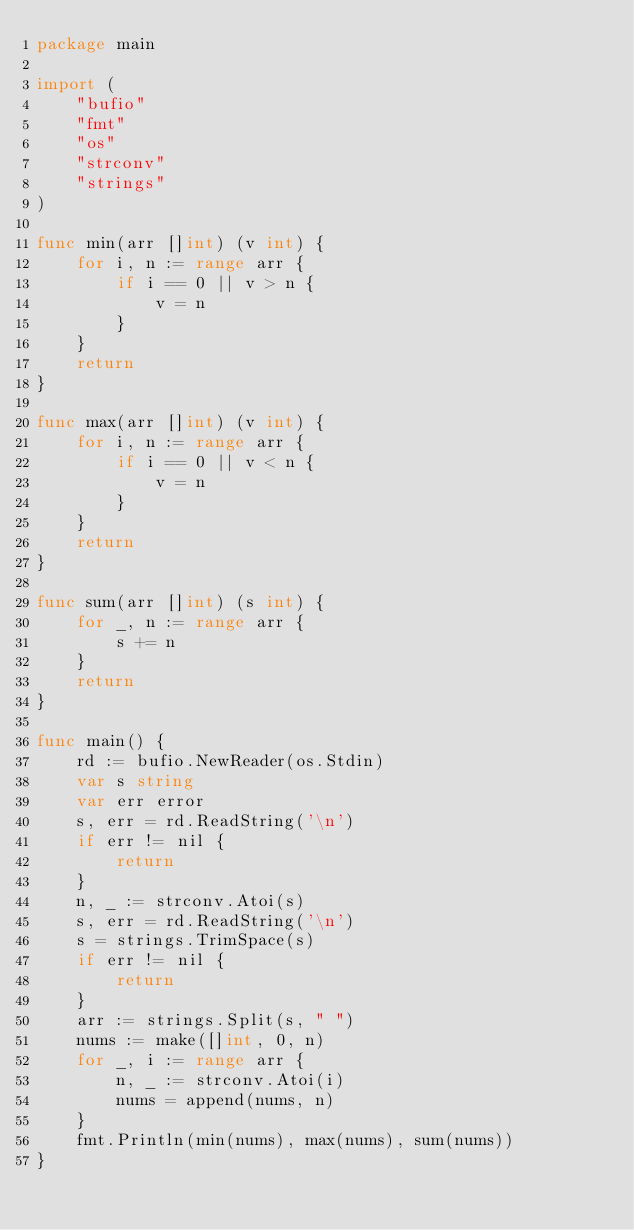<code> <loc_0><loc_0><loc_500><loc_500><_Go_>package main

import (
	"bufio"
	"fmt"
	"os"
	"strconv"
	"strings"
)

func min(arr []int) (v int) {
	for i, n := range arr {
		if i == 0 || v > n {
			v = n
		}
	}
	return
}

func max(arr []int) (v int) {
	for i, n := range arr {
		if i == 0 || v < n {
			v = n
		}
	}
	return
}

func sum(arr []int) (s int) {
	for _, n := range arr {
		s += n
	}
	return
}

func main() {
	rd := bufio.NewReader(os.Stdin)
	var s string
	var err error
	s, err = rd.ReadString('\n')
	if err != nil {
		return
	}
	n, _ := strconv.Atoi(s)
	s, err = rd.ReadString('\n')
	s = strings.TrimSpace(s)
	if err != nil {
		return
	}
	arr := strings.Split(s, " ")
	nums := make([]int, 0, n)
	for _, i := range arr {
		n, _ := strconv.Atoi(i)
		nums = append(nums, n)
	}
	fmt.Println(min(nums), max(nums), sum(nums))
}

</code> 